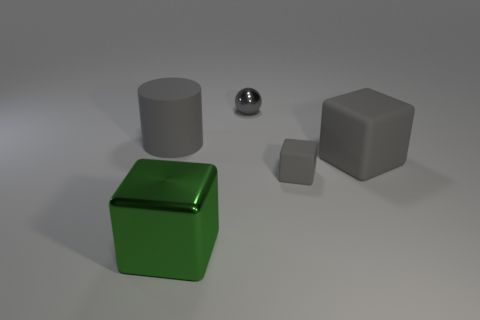What number of large objects are on the right side of the gray ball and on the left side of the big green thing?
Offer a terse response. 0. How many other big green metal objects have the same shape as the large metallic thing?
Offer a very short reply. 0. Do the large green thing and the tiny gray block have the same material?
Your answer should be compact. No. There is a big gray thing on the left side of the gray metallic sphere that is on the right side of the large metallic object; what is its shape?
Ensure brevity in your answer.  Cylinder. There is a gray matte block behind the tiny rubber block; how many objects are on the left side of it?
Provide a short and direct response. 4. There is a large object that is both on the right side of the large cylinder and behind the large green metal block; what is its material?
Your response must be concise. Rubber. What is the shape of the rubber thing that is the same size as the rubber cylinder?
Offer a very short reply. Cube. The big block that is right of the shiny object in front of the big gray rubber object on the left side of the tiny gray ball is what color?
Your answer should be very brief. Gray. What number of objects are objects that are on the left side of the small gray shiny sphere or green shiny objects?
Ensure brevity in your answer.  2. There is a green thing that is the same size as the cylinder; what is its material?
Your answer should be compact. Metal. 